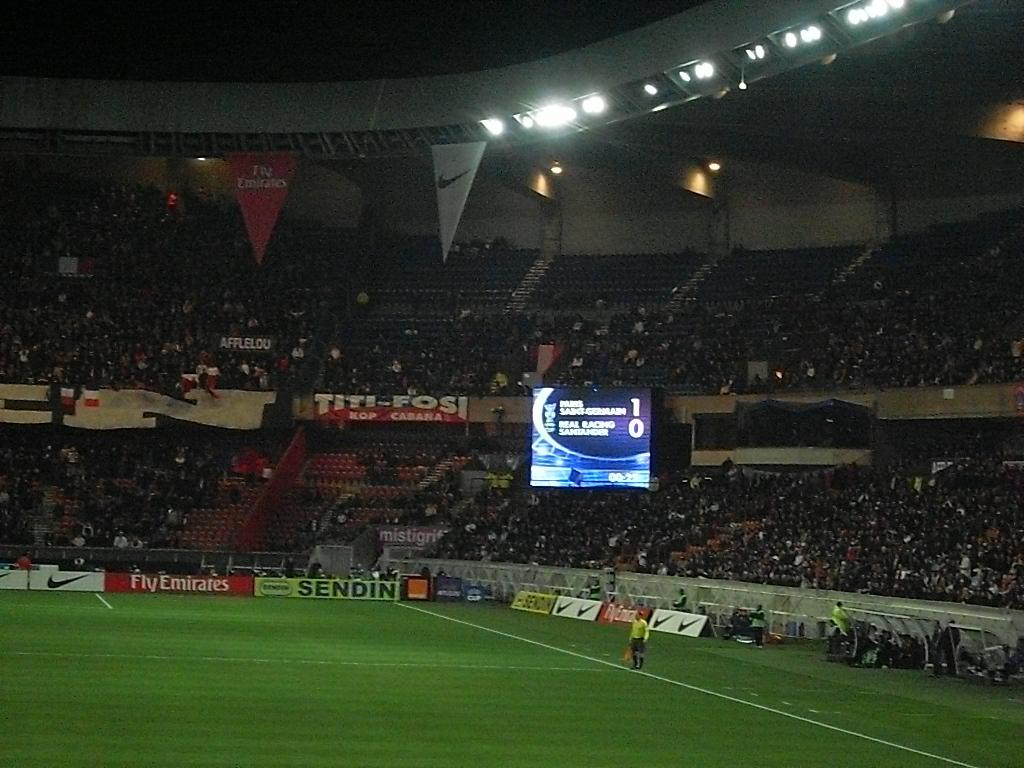<image>
Share a concise interpretation of the image provided. A soccer stadium scoreboard brightly displays a score of 1-0 at night. 